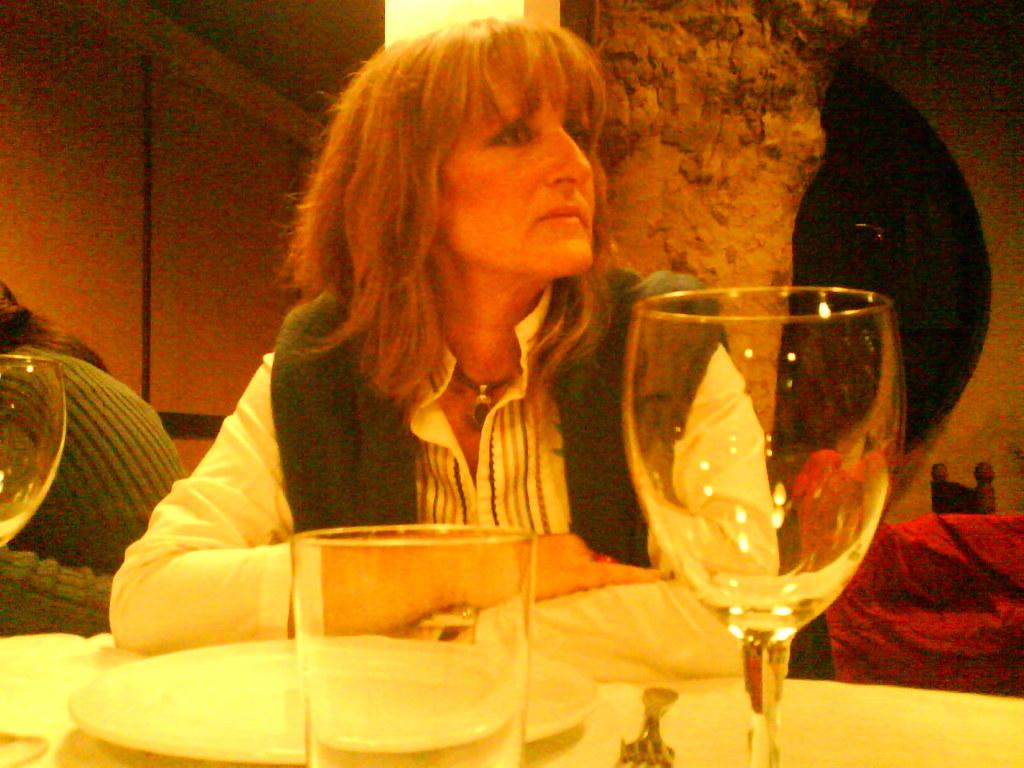What are the people in the image doing? The persons in the image are sitting on chairs. What is placed in front of the chairs? A table is placed in front of the chairs. What items can be seen on the table? There is crockery and cutlery on the table. Can you see a rabbit shaking an iron in the image? No, there is no rabbit or iron present in the image. 